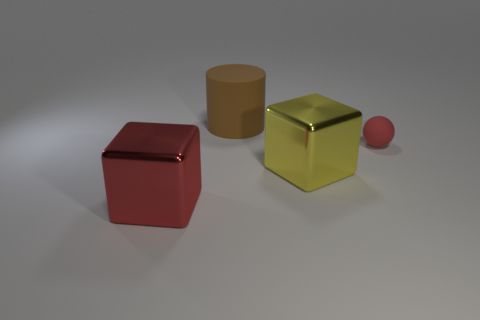Add 3 red blocks. How many objects exist? 7 Subtract all cylinders. How many objects are left? 3 Add 4 tiny matte objects. How many tiny matte objects exist? 5 Subtract 0 gray balls. How many objects are left? 4 Subtract all large yellow things. Subtract all red shiny cylinders. How many objects are left? 3 Add 1 spheres. How many spheres are left? 2 